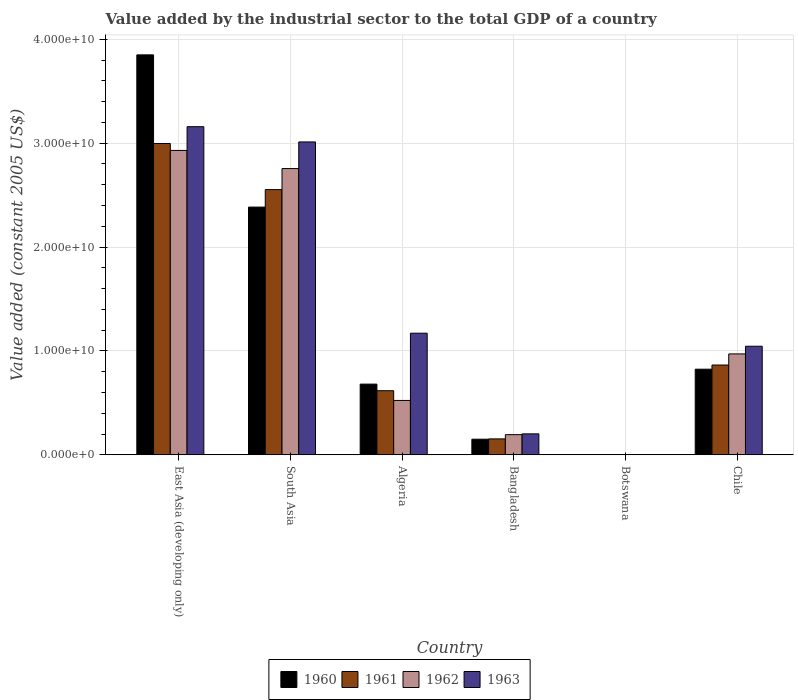How many groups of bars are there?
Offer a terse response. 6. Are the number of bars on each tick of the X-axis equal?
Provide a succinct answer. Yes. How many bars are there on the 2nd tick from the right?
Ensure brevity in your answer.  4. What is the value added by the industrial sector in 1963 in Chile?
Make the answer very short. 1.04e+1. Across all countries, what is the maximum value added by the industrial sector in 1963?
Your answer should be very brief. 3.16e+1. Across all countries, what is the minimum value added by the industrial sector in 1961?
Ensure brevity in your answer.  1.92e+07. In which country was the value added by the industrial sector in 1960 maximum?
Provide a succinct answer. East Asia (developing only). In which country was the value added by the industrial sector in 1961 minimum?
Provide a short and direct response. Botswana. What is the total value added by the industrial sector in 1962 in the graph?
Your response must be concise. 7.37e+1. What is the difference between the value added by the industrial sector in 1960 in Bangladesh and that in South Asia?
Your answer should be compact. -2.23e+1. What is the difference between the value added by the industrial sector in 1963 in Chile and the value added by the industrial sector in 1961 in Bangladesh?
Offer a very short reply. 8.92e+09. What is the average value added by the industrial sector in 1961 per country?
Provide a succinct answer. 1.20e+1. What is the difference between the value added by the industrial sector of/in 1963 and value added by the industrial sector of/in 1962 in Botswana?
Your answer should be compact. -1.48e+06. In how many countries, is the value added by the industrial sector in 1962 greater than 18000000000 US$?
Give a very brief answer. 2. What is the ratio of the value added by the industrial sector in 1963 in East Asia (developing only) to that in South Asia?
Your answer should be compact. 1.05. What is the difference between the highest and the second highest value added by the industrial sector in 1961?
Provide a succinct answer. 4.43e+09. What is the difference between the highest and the lowest value added by the industrial sector in 1962?
Your response must be concise. 2.93e+1. In how many countries, is the value added by the industrial sector in 1962 greater than the average value added by the industrial sector in 1962 taken over all countries?
Provide a succinct answer. 2. Is the sum of the value added by the industrial sector in 1961 in Bangladesh and South Asia greater than the maximum value added by the industrial sector in 1962 across all countries?
Your response must be concise. No. Are all the bars in the graph horizontal?
Offer a terse response. No. Does the graph contain grids?
Offer a terse response. Yes. How are the legend labels stacked?
Your answer should be very brief. Horizontal. What is the title of the graph?
Your answer should be compact. Value added by the industrial sector to the total GDP of a country. What is the label or title of the Y-axis?
Your response must be concise. Value added (constant 2005 US$). What is the Value added (constant 2005 US$) in 1960 in East Asia (developing only)?
Your response must be concise. 3.85e+1. What is the Value added (constant 2005 US$) of 1961 in East Asia (developing only)?
Ensure brevity in your answer.  3.00e+1. What is the Value added (constant 2005 US$) in 1962 in East Asia (developing only)?
Your answer should be compact. 2.93e+1. What is the Value added (constant 2005 US$) in 1963 in East Asia (developing only)?
Provide a succinct answer. 3.16e+1. What is the Value added (constant 2005 US$) in 1960 in South Asia?
Your answer should be very brief. 2.38e+1. What is the Value added (constant 2005 US$) of 1961 in South Asia?
Your answer should be very brief. 2.55e+1. What is the Value added (constant 2005 US$) of 1962 in South Asia?
Your response must be concise. 2.76e+1. What is the Value added (constant 2005 US$) of 1963 in South Asia?
Offer a very short reply. 3.01e+1. What is the Value added (constant 2005 US$) of 1960 in Algeria?
Keep it short and to the point. 6.80e+09. What is the Value added (constant 2005 US$) of 1961 in Algeria?
Provide a short and direct response. 6.17e+09. What is the Value added (constant 2005 US$) in 1962 in Algeria?
Your answer should be compact. 5.23e+09. What is the Value added (constant 2005 US$) in 1963 in Algeria?
Provide a succinct answer. 1.17e+1. What is the Value added (constant 2005 US$) in 1960 in Bangladesh?
Give a very brief answer. 1.50e+09. What is the Value added (constant 2005 US$) of 1961 in Bangladesh?
Keep it short and to the point. 1.53e+09. What is the Value added (constant 2005 US$) of 1962 in Bangladesh?
Offer a very short reply. 1.94e+09. What is the Value added (constant 2005 US$) in 1963 in Bangladesh?
Offer a terse response. 2.01e+09. What is the Value added (constant 2005 US$) of 1960 in Botswana?
Provide a succinct answer. 1.96e+07. What is the Value added (constant 2005 US$) of 1961 in Botswana?
Your answer should be compact. 1.92e+07. What is the Value added (constant 2005 US$) in 1962 in Botswana?
Keep it short and to the point. 1.98e+07. What is the Value added (constant 2005 US$) of 1963 in Botswana?
Offer a very short reply. 1.83e+07. What is the Value added (constant 2005 US$) in 1960 in Chile?
Give a very brief answer. 8.24e+09. What is the Value added (constant 2005 US$) of 1961 in Chile?
Provide a succinct answer. 8.64e+09. What is the Value added (constant 2005 US$) of 1962 in Chile?
Provide a short and direct response. 9.71e+09. What is the Value added (constant 2005 US$) of 1963 in Chile?
Ensure brevity in your answer.  1.04e+1. Across all countries, what is the maximum Value added (constant 2005 US$) in 1960?
Your response must be concise. 3.85e+1. Across all countries, what is the maximum Value added (constant 2005 US$) in 1961?
Your answer should be compact. 3.00e+1. Across all countries, what is the maximum Value added (constant 2005 US$) in 1962?
Provide a short and direct response. 2.93e+1. Across all countries, what is the maximum Value added (constant 2005 US$) in 1963?
Provide a succinct answer. 3.16e+1. Across all countries, what is the minimum Value added (constant 2005 US$) in 1960?
Provide a short and direct response. 1.96e+07. Across all countries, what is the minimum Value added (constant 2005 US$) of 1961?
Provide a short and direct response. 1.92e+07. Across all countries, what is the minimum Value added (constant 2005 US$) in 1962?
Your answer should be very brief. 1.98e+07. Across all countries, what is the minimum Value added (constant 2005 US$) of 1963?
Keep it short and to the point. 1.83e+07. What is the total Value added (constant 2005 US$) in 1960 in the graph?
Offer a terse response. 7.89e+1. What is the total Value added (constant 2005 US$) of 1961 in the graph?
Keep it short and to the point. 7.18e+1. What is the total Value added (constant 2005 US$) of 1962 in the graph?
Ensure brevity in your answer.  7.37e+1. What is the total Value added (constant 2005 US$) in 1963 in the graph?
Offer a very short reply. 8.59e+1. What is the difference between the Value added (constant 2005 US$) in 1960 in East Asia (developing only) and that in South Asia?
Ensure brevity in your answer.  1.47e+1. What is the difference between the Value added (constant 2005 US$) in 1961 in East Asia (developing only) and that in South Asia?
Offer a terse response. 4.43e+09. What is the difference between the Value added (constant 2005 US$) of 1962 in East Asia (developing only) and that in South Asia?
Provide a short and direct response. 1.74e+09. What is the difference between the Value added (constant 2005 US$) of 1963 in East Asia (developing only) and that in South Asia?
Ensure brevity in your answer.  1.47e+09. What is the difference between the Value added (constant 2005 US$) in 1960 in East Asia (developing only) and that in Algeria?
Give a very brief answer. 3.17e+1. What is the difference between the Value added (constant 2005 US$) of 1961 in East Asia (developing only) and that in Algeria?
Ensure brevity in your answer.  2.38e+1. What is the difference between the Value added (constant 2005 US$) in 1962 in East Asia (developing only) and that in Algeria?
Keep it short and to the point. 2.41e+1. What is the difference between the Value added (constant 2005 US$) in 1963 in East Asia (developing only) and that in Algeria?
Ensure brevity in your answer.  1.99e+1. What is the difference between the Value added (constant 2005 US$) of 1960 in East Asia (developing only) and that in Bangladesh?
Offer a terse response. 3.70e+1. What is the difference between the Value added (constant 2005 US$) of 1961 in East Asia (developing only) and that in Bangladesh?
Give a very brief answer. 2.84e+1. What is the difference between the Value added (constant 2005 US$) in 1962 in East Asia (developing only) and that in Bangladesh?
Your answer should be very brief. 2.74e+1. What is the difference between the Value added (constant 2005 US$) of 1963 in East Asia (developing only) and that in Bangladesh?
Ensure brevity in your answer.  2.96e+1. What is the difference between the Value added (constant 2005 US$) of 1960 in East Asia (developing only) and that in Botswana?
Keep it short and to the point. 3.85e+1. What is the difference between the Value added (constant 2005 US$) in 1961 in East Asia (developing only) and that in Botswana?
Keep it short and to the point. 2.99e+1. What is the difference between the Value added (constant 2005 US$) in 1962 in East Asia (developing only) and that in Botswana?
Your answer should be very brief. 2.93e+1. What is the difference between the Value added (constant 2005 US$) in 1963 in East Asia (developing only) and that in Botswana?
Make the answer very short. 3.16e+1. What is the difference between the Value added (constant 2005 US$) in 1960 in East Asia (developing only) and that in Chile?
Offer a terse response. 3.03e+1. What is the difference between the Value added (constant 2005 US$) of 1961 in East Asia (developing only) and that in Chile?
Offer a terse response. 2.13e+1. What is the difference between the Value added (constant 2005 US$) in 1962 in East Asia (developing only) and that in Chile?
Offer a terse response. 1.96e+1. What is the difference between the Value added (constant 2005 US$) of 1963 in East Asia (developing only) and that in Chile?
Keep it short and to the point. 2.11e+1. What is the difference between the Value added (constant 2005 US$) of 1960 in South Asia and that in Algeria?
Offer a terse response. 1.70e+1. What is the difference between the Value added (constant 2005 US$) in 1961 in South Asia and that in Algeria?
Provide a short and direct response. 1.94e+1. What is the difference between the Value added (constant 2005 US$) of 1962 in South Asia and that in Algeria?
Your answer should be compact. 2.23e+1. What is the difference between the Value added (constant 2005 US$) of 1963 in South Asia and that in Algeria?
Your answer should be very brief. 1.84e+1. What is the difference between the Value added (constant 2005 US$) in 1960 in South Asia and that in Bangladesh?
Your answer should be very brief. 2.23e+1. What is the difference between the Value added (constant 2005 US$) in 1961 in South Asia and that in Bangladesh?
Make the answer very short. 2.40e+1. What is the difference between the Value added (constant 2005 US$) in 1962 in South Asia and that in Bangladesh?
Your response must be concise. 2.56e+1. What is the difference between the Value added (constant 2005 US$) in 1963 in South Asia and that in Bangladesh?
Give a very brief answer. 2.81e+1. What is the difference between the Value added (constant 2005 US$) of 1960 in South Asia and that in Botswana?
Give a very brief answer. 2.38e+1. What is the difference between the Value added (constant 2005 US$) in 1961 in South Asia and that in Botswana?
Your answer should be very brief. 2.55e+1. What is the difference between the Value added (constant 2005 US$) in 1962 in South Asia and that in Botswana?
Offer a terse response. 2.75e+1. What is the difference between the Value added (constant 2005 US$) in 1963 in South Asia and that in Botswana?
Make the answer very short. 3.01e+1. What is the difference between the Value added (constant 2005 US$) of 1960 in South Asia and that in Chile?
Ensure brevity in your answer.  1.56e+1. What is the difference between the Value added (constant 2005 US$) in 1961 in South Asia and that in Chile?
Ensure brevity in your answer.  1.69e+1. What is the difference between the Value added (constant 2005 US$) in 1962 in South Asia and that in Chile?
Keep it short and to the point. 1.78e+1. What is the difference between the Value added (constant 2005 US$) of 1963 in South Asia and that in Chile?
Provide a succinct answer. 1.97e+1. What is the difference between the Value added (constant 2005 US$) in 1960 in Algeria and that in Bangladesh?
Make the answer very short. 5.30e+09. What is the difference between the Value added (constant 2005 US$) of 1961 in Algeria and that in Bangladesh?
Offer a very short reply. 4.64e+09. What is the difference between the Value added (constant 2005 US$) of 1962 in Algeria and that in Bangladesh?
Your answer should be very brief. 3.29e+09. What is the difference between the Value added (constant 2005 US$) of 1963 in Algeria and that in Bangladesh?
Your answer should be compact. 9.69e+09. What is the difference between the Value added (constant 2005 US$) of 1960 in Algeria and that in Botswana?
Ensure brevity in your answer.  6.78e+09. What is the difference between the Value added (constant 2005 US$) of 1961 in Algeria and that in Botswana?
Offer a terse response. 6.15e+09. What is the difference between the Value added (constant 2005 US$) of 1962 in Algeria and that in Botswana?
Provide a short and direct response. 5.21e+09. What is the difference between the Value added (constant 2005 US$) in 1963 in Algeria and that in Botswana?
Offer a terse response. 1.17e+1. What is the difference between the Value added (constant 2005 US$) in 1960 in Algeria and that in Chile?
Offer a very short reply. -1.44e+09. What is the difference between the Value added (constant 2005 US$) of 1961 in Algeria and that in Chile?
Your answer should be very brief. -2.47e+09. What is the difference between the Value added (constant 2005 US$) of 1962 in Algeria and that in Chile?
Keep it short and to the point. -4.48e+09. What is the difference between the Value added (constant 2005 US$) in 1963 in Algeria and that in Chile?
Make the answer very short. 1.26e+09. What is the difference between the Value added (constant 2005 US$) in 1960 in Bangladesh and that in Botswana?
Offer a very short reply. 1.48e+09. What is the difference between the Value added (constant 2005 US$) in 1961 in Bangladesh and that in Botswana?
Your response must be concise. 1.51e+09. What is the difference between the Value added (constant 2005 US$) in 1962 in Bangladesh and that in Botswana?
Your answer should be compact. 1.92e+09. What is the difference between the Value added (constant 2005 US$) of 1963 in Bangladesh and that in Botswana?
Keep it short and to the point. 2.00e+09. What is the difference between the Value added (constant 2005 US$) in 1960 in Bangladesh and that in Chile?
Provide a short and direct response. -6.74e+09. What is the difference between the Value added (constant 2005 US$) in 1961 in Bangladesh and that in Chile?
Ensure brevity in your answer.  -7.11e+09. What is the difference between the Value added (constant 2005 US$) of 1962 in Bangladesh and that in Chile?
Your answer should be compact. -7.77e+09. What is the difference between the Value added (constant 2005 US$) in 1963 in Bangladesh and that in Chile?
Keep it short and to the point. -8.43e+09. What is the difference between the Value added (constant 2005 US$) in 1960 in Botswana and that in Chile?
Keep it short and to the point. -8.22e+09. What is the difference between the Value added (constant 2005 US$) in 1961 in Botswana and that in Chile?
Make the answer very short. -8.62e+09. What is the difference between the Value added (constant 2005 US$) of 1962 in Botswana and that in Chile?
Offer a terse response. -9.69e+09. What is the difference between the Value added (constant 2005 US$) in 1963 in Botswana and that in Chile?
Ensure brevity in your answer.  -1.04e+1. What is the difference between the Value added (constant 2005 US$) in 1960 in East Asia (developing only) and the Value added (constant 2005 US$) in 1961 in South Asia?
Your answer should be very brief. 1.30e+1. What is the difference between the Value added (constant 2005 US$) of 1960 in East Asia (developing only) and the Value added (constant 2005 US$) of 1962 in South Asia?
Your answer should be compact. 1.09e+1. What is the difference between the Value added (constant 2005 US$) in 1960 in East Asia (developing only) and the Value added (constant 2005 US$) in 1963 in South Asia?
Provide a short and direct response. 8.38e+09. What is the difference between the Value added (constant 2005 US$) of 1961 in East Asia (developing only) and the Value added (constant 2005 US$) of 1962 in South Asia?
Offer a terse response. 2.41e+09. What is the difference between the Value added (constant 2005 US$) of 1961 in East Asia (developing only) and the Value added (constant 2005 US$) of 1963 in South Asia?
Provide a succinct answer. -1.54e+08. What is the difference between the Value added (constant 2005 US$) of 1962 in East Asia (developing only) and the Value added (constant 2005 US$) of 1963 in South Asia?
Offer a very short reply. -8.18e+08. What is the difference between the Value added (constant 2005 US$) of 1960 in East Asia (developing only) and the Value added (constant 2005 US$) of 1961 in Algeria?
Keep it short and to the point. 3.23e+1. What is the difference between the Value added (constant 2005 US$) of 1960 in East Asia (developing only) and the Value added (constant 2005 US$) of 1962 in Algeria?
Your response must be concise. 3.33e+1. What is the difference between the Value added (constant 2005 US$) in 1960 in East Asia (developing only) and the Value added (constant 2005 US$) in 1963 in Algeria?
Make the answer very short. 2.68e+1. What is the difference between the Value added (constant 2005 US$) of 1961 in East Asia (developing only) and the Value added (constant 2005 US$) of 1962 in Algeria?
Provide a short and direct response. 2.47e+1. What is the difference between the Value added (constant 2005 US$) in 1961 in East Asia (developing only) and the Value added (constant 2005 US$) in 1963 in Algeria?
Make the answer very short. 1.83e+1. What is the difference between the Value added (constant 2005 US$) in 1962 in East Asia (developing only) and the Value added (constant 2005 US$) in 1963 in Algeria?
Provide a succinct answer. 1.76e+1. What is the difference between the Value added (constant 2005 US$) of 1960 in East Asia (developing only) and the Value added (constant 2005 US$) of 1961 in Bangladesh?
Offer a terse response. 3.70e+1. What is the difference between the Value added (constant 2005 US$) of 1960 in East Asia (developing only) and the Value added (constant 2005 US$) of 1962 in Bangladesh?
Keep it short and to the point. 3.66e+1. What is the difference between the Value added (constant 2005 US$) in 1960 in East Asia (developing only) and the Value added (constant 2005 US$) in 1963 in Bangladesh?
Your answer should be very brief. 3.65e+1. What is the difference between the Value added (constant 2005 US$) in 1961 in East Asia (developing only) and the Value added (constant 2005 US$) in 1962 in Bangladesh?
Keep it short and to the point. 2.80e+1. What is the difference between the Value added (constant 2005 US$) in 1961 in East Asia (developing only) and the Value added (constant 2005 US$) in 1963 in Bangladesh?
Provide a succinct answer. 2.79e+1. What is the difference between the Value added (constant 2005 US$) of 1962 in East Asia (developing only) and the Value added (constant 2005 US$) of 1963 in Bangladesh?
Offer a terse response. 2.73e+1. What is the difference between the Value added (constant 2005 US$) in 1960 in East Asia (developing only) and the Value added (constant 2005 US$) in 1961 in Botswana?
Provide a succinct answer. 3.85e+1. What is the difference between the Value added (constant 2005 US$) of 1960 in East Asia (developing only) and the Value added (constant 2005 US$) of 1962 in Botswana?
Give a very brief answer. 3.85e+1. What is the difference between the Value added (constant 2005 US$) of 1960 in East Asia (developing only) and the Value added (constant 2005 US$) of 1963 in Botswana?
Your answer should be compact. 3.85e+1. What is the difference between the Value added (constant 2005 US$) of 1961 in East Asia (developing only) and the Value added (constant 2005 US$) of 1962 in Botswana?
Offer a terse response. 2.99e+1. What is the difference between the Value added (constant 2005 US$) in 1961 in East Asia (developing only) and the Value added (constant 2005 US$) in 1963 in Botswana?
Your answer should be compact. 2.99e+1. What is the difference between the Value added (constant 2005 US$) of 1962 in East Asia (developing only) and the Value added (constant 2005 US$) of 1963 in Botswana?
Provide a short and direct response. 2.93e+1. What is the difference between the Value added (constant 2005 US$) in 1960 in East Asia (developing only) and the Value added (constant 2005 US$) in 1961 in Chile?
Your response must be concise. 2.99e+1. What is the difference between the Value added (constant 2005 US$) of 1960 in East Asia (developing only) and the Value added (constant 2005 US$) of 1962 in Chile?
Give a very brief answer. 2.88e+1. What is the difference between the Value added (constant 2005 US$) in 1960 in East Asia (developing only) and the Value added (constant 2005 US$) in 1963 in Chile?
Offer a very short reply. 2.80e+1. What is the difference between the Value added (constant 2005 US$) of 1961 in East Asia (developing only) and the Value added (constant 2005 US$) of 1962 in Chile?
Your answer should be compact. 2.02e+1. What is the difference between the Value added (constant 2005 US$) of 1961 in East Asia (developing only) and the Value added (constant 2005 US$) of 1963 in Chile?
Offer a very short reply. 1.95e+1. What is the difference between the Value added (constant 2005 US$) of 1962 in East Asia (developing only) and the Value added (constant 2005 US$) of 1963 in Chile?
Provide a short and direct response. 1.88e+1. What is the difference between the Value added (constant 2005 US$) of 1960 in South Asia and the Value added (constant 2005 US$) of 1961 in Algeria?
Your answer should be compact. 1.77e+1. What is the difference between the Value added (constant 2005 US$) in 1960 in South Asia and the Value added (constant 2005 US$) in 1962 in Algeria?
Your answer should be compact. 1.86e+1. What is the difference between the Value added (constant 2005 US$) of 1960 in South Asia and the Value added (constant 2005 US$) of 1963 in Algeria?
Your answer should be very brief. 1.21e+1. What is the difference between the Value added (constant 2005 US$) in 1961 in South Asia and the Value added (constant 2005 US$) in 1962 in Algeria?
Give a very brief answer. 2.03e+1. What is the difference between the Value added (constant 2005 US$) of 1961 in South Asia and the Value added (constant 2005 US$) of 1963 in Algeria?
Make the answer very short. 1.38e+1. What is the difference between the Value added (constant 2005 US$) of 1962 in South Asia and the Value added (constant 2005 US$) of 1963 in Algeria?
Your answer should be very brief. 1.58e+1. What is the difference between the Value added (constant 2005 US$) in 1960 in South Asia and the Value added (constant 2005 US$) in 1961 in Bangladesh?
Offer a terse response. 2.23e+1. What is the difference between the Value added (constant 2005 US$) of 1960 in South Asia and the Value added (constant 2005 US$) of 1962 in Bangladesh?
Give a very brief answer. 2.19e+1. What is the difference between the Value added (constant 2005 US$) in 1960 in South Asia and the Value added (constant 2005 US$) in 1963 in Bangladesh?
Provide a succinct answer. 2.18e+1. What is the difference between the Value added (constant 2005 US$) in 1961 in South Asia and the Value added (constant 2005 US$) in 1962 in Bangladesh?
Keep it short and to the point. 2.36e+1. What is the difference between the Value added (constant 2005 US$) in 1961 in South Asia and the Value added (constant 2005 US$) in 1963 in Bangladesh?
Offer a very short reply. 2.35e+1. What is the difference between the Value added (constant 2005 US$) of 1962 in South Asia and the Value added (constant 2005 US$) of 1963 in Bangladesh?
Offer a terse response. 2.55e+1. What is the difference between the Value added (constant 2005 US$) in 1960 in South Asia and the Value added (constant 2005 US$) in 1961 in Botswana?
Offer a very short reply. 2.38e+1. What is the difference between the Value added (constant 2005 US$) in 1960 in South Asia and the Value added (constant 2005 US$) in 1962 in Botswana?
Make the answer very short. 2.38e+1. What is the difference between the Value added (constant 2005 US$) of 1960 in South Asia and the Value added (constant 2005 US$) of 1963 in Botswana?
Your response must be concise. 2.38e+1. What is the difference between the Value added (constant 2005 US$) in 1961 in South Asia and the Value added (constant 2005 US$) in 1962 in Botswana?
Provide a succinct answer. 2.55e+1. What is the difference between the Value added (constant 2005 US$) in 1961 in South Asia and the Value added (constant 2005 US$) in 1963 in Botswana?
Keep it short and to the point. 2.55e+1. What is the difference between the Value added (constant 2005 US$) in 1962 in South Asia and the Value added (constant 2005 US$) in 1963 in Botswana?
Provide a short and direct response. 2.75e+1. What is the difference between the Value added (constant 2005 US$) of 1960 in South Asia and the Value added (constant 2005 US$) of 1961 in Chile?
Keep it short and to the point. 1.52e+1. What is the difference between the Value added (constant 2005 US$) of 1960 in South Asia and the Value added (constant 2005 US$) of 1962 in Chile?
Provide a succinct answer. 1.41e+1. What is the difference between the Value added (constant 2005 US$) in 1960 in South Asia and the Value added (constant 2005 US$) in 1963 in Chile?
Ensure brevity in your answer.  1.34e+1. What is the difference between the Value added (constant 2005 US$) of 1961 in South Asia and the Value added (constant 2005 US$) of 1962 in Chile?
Offer a very short reply. 1.58e+1. What is the difference between the Value added (constant 2005 US$) of 1961 in South Asia and the Value added (constant 2005 US$) of 1963 in Chile?
Your response must be concise. 1.51e+1. What is the difference between the Value added (constant 2005 US$) of 1962 in South Asia and the Value added (constant 2005 US$) of 1963 in Chile?
Your answer should be compact. 1.71e+1. What is the difference between the Value added (constant 2005 US$) of 1960 in Algeria and the Value added (constant 2005 US$) of 1961 in Bangladesh?
Offer a terse response. 5.27e+09. What is the difference between the Value added (constant 2005 US$) of 1960 in Algeria and the Value added (constant 2005 US$) of 1962 in Bangladesh?
Make the answer very short. 4.86e+09. What is the difference between the Value added (constant 2005 US$) in 1960 in Algeria and the Value added (constant 2005 US$) in 1963 in Bangladesh?
Provide a short and direct response. 4.79e+09. What is the difference between the Value added (constant 2005 US$) of 1961 in Algeria and the Value added (constant 2005 US$) of 1962 in Bangladesh?
Ensure brevity in your answer.  4.23e+09. What is the difference between the Value added (constant 2005 US$) of 1961 in Algeria and the Value added (constant 2005 US$) of 1963 in Bangladesh?
Offer a very short reply. 4.15e+09. What is the difference between the Value added (constant 2005 US$) in 1962 in Algeria and the Value added (constant 2005 US$) in 1963 in Bangladesh?
Your answer should be very brief. 3.22e+09. What is the difference between the Value added (constant 2005 US$) in 1960 in Algeria and the Value added (constant 2005 US$) in 1961 in Botswana?
Your answer should be very brief. 6.78e+09. What is the difference between the Value added (constant 2005 US$) of 1960 in Algeria and the Value added (constant 2005 US$) of 1962 in Botswana?
Provide a succinct answer. 6.78e+09. What is the difference between the Value added (constant 2005 US$) in 1960 in Algeria and the Value added (constant 2005 US$) in 1963 in Botswana?
Offer a very short reply. 6.78e+09. What is the difference between the Value added (constant 2005 US$) in 1961 in Algeria and the Value added (constant 2005 US$) in 1962 in Botswana?
Your answer should be compact. 6.15e+09. What is the difference between the Value added (constant 2005 US$) of 1961 in Algeria and the Value added (constant 2005 US$) of 1963 in Botswana?
Your answer should be compact. 6.15e+09. What is the difference between the Value added (constant 2005 US$) in 1962 in Algeria and the Value added (constant 2005 US$) in 1963 in Botswana?
Your answer should be very brief. 5.21e+09. What is the difference between the Value added (constant 2005 US$) in 1960 in Algeria and the Value added (constant 2005 US$) in 1961 in Chile?
Your answer should be compact. -1.84e+09. What is the difference between the Value added (constant 2005 US$) in 1960 in Algeria and the Value added (constant 2005 US$) in 1962 in Chile?
Ensure brevity in your answer.  -2.91e+09. What is the difference between the Value added (constant 2005 US$) of 1960 in Algeria and the Value added (constant 2005 US$) of 1963 in Chile?
Your answer should be compact. -3.65e+09. What is the difference between the Value added (constant 2005 US$) in 1961 in Algeria and the Value added (constant 2005 US$) in 1962 in Chile?
Ensure brevity in your answer.  -3.54e+09. What is the difference between the Value added (constant 2005 US$) of 1961 in Algeria and the Value added (constant 2005 US$) of 1963 in Chile?
Make the answer very short. -4.28e+09. What is the difference between the Value added (constant 2005 US$) in 1962 in Algeria and the Value added (constant 2005 US$) in 1963 in Chile?
Offer a terse response. -5.22e+09. What is the difference between the Value added (constant 2005 US$) in 1960 in Bangladesh and the Value added (constant 2005 US$) in 1961 in Botswana?
Offer a very short reply. 1.48e+09. What is the difference between the Value added (constant 2005 US$) in 1960 in Bangladesh and the Value added (constant 2005 US$) in 1962 in Botswana?
Your answer should be very brief. 1.48e+09. What is the difference between the Value added (constant 2005 US$) in 1960 in Bangladesh and the Value added (constant 2005 US$) in 1963 in Botswana?
Provide a succinct answer. 1.48e+09. What is the difference between the Value added (constant 2005 US$) in 1961 in Bangladesh and the Value added (constant 2005 US$) in 1962 in Botswana?
Provide a short and direct response. 1.51e+09. What is the difference between the Value added (constant 2005 US$) in 1961 in Bangladesh and the Value added (constant 2005 US$) in 1963 in Botswana?
Provide a short and direct response. 1.51e+09. What is the difference between the Value added (constant 2005 US$) in 1962 in Bangladesh and the Value added (constant 2005 US$) in 1963 in Botswana?
Offer a very short reply. 1.92e+09. What is the difference between the Value added (constant 2005 US$) in 1960 in Bangladesh and the Value added (constant 2005 US$) in 1961 in Chile?
Your answer should be very brief. -7.14e+09. What is the difference between the Value added (constant 2005 US$) of 1960 in Bangladesh and the Value added (constant 2005 US$) of 1962 in Chile?
Your answer should be compact. -8.21e+09. What is the difference between the Value added (constant 2005 US$) of 1960 in Bangladesh and the Value added (constant 2005 US$) of 1963 in Chile?
Make the answer very short. -8.95e+09. What is the difference between the Value added (constant 2005 US$) of 1961 in Bangladesh and the Value added (constant 2005 US$) of 1962 in Chile?
Provide a short and direct response. -8.18e+09. What is the difference between the Value added (constant 2005 US$) of 1961 in Bangladesh and the Value added (constant 2005 US$) of 1963 in Chile?
Offer a very short reply. -8.92e+09. What is the difference between the Value added (constant 2005 US$) in 1962 in Bangladesh and the Value added (constant 2005 US$) in 1963 in Chile?
Give a very brief answer. -8.51e+09. What is the difference between the Value added (constant 2005 US$) in 1960 in Botswana and the Value added (constant 2005 US$) in 1961 in Chile?
Provide a short and direct response. -8.62e+09. What is the difference between the Value added (constant 2005 US$) in 1960 in Botswana and the Value added (constant 2005 US$) in 1962 in Chile?
Your response must be concise. -9.69e+09. What is the difference between the Value added (constant 2005 US$) of 1960 in Botswana and the Value added (constant 2005 US$) of 1963 in Chile?
Ensure brevity in your answer.  -1.04e+1. What is the difference between the Value added (constant 2005 US$) of 1961 in Botswana and the Value added (constant 2005 US$) of 1962 in Chile?
Your response must be concise. -9.69e+09. What is the difference between the Value added (constant 2005 US$) of 1961 in Botswana and the Value added (constant 2005 US$) of 1963 in Chile?
Provide a succinct answer. -1.04e+1. What is the difference between the Value added (constant 2005 US$) in 1962 in Botswana and the Value added (constant 2005 US$) in 1963 in Chile?
Make the answer very short. -1.04e+1. What is the average Value added (constant 2005 US$) of 1960 per country?
Your answer should be very brief. 1.31e+1. What is the average Value added (constant 2005 US$) in 1961 per country?
Offer a terse response. 1.20e+1. What is the average Value added (constant 2005 US$) in 1962 per country?
Your answer should be very brief. 1.23e+1. What is the average Value added (constant 2005 US$) of 1963 per country?
Your answer should be very brief. 1.43e+1. What is the difference between the Value added (constant 2005 US$) of 1960 and Value added (constant 2005 US$) of 1961 in East Asia (developing only)?
Provide a succinct answer. 8.53e+09. What is the difference between the Value added (constant 2005 US$) in 1960 and Value added (constant 2005 US$) in 1962 in East Asia (developing only)?
Give a very brief answer. 9.20e+09. What is the difference between the Value added (constant 2005 US$) in 1960 and Value added (constant 2005 US$) in 1963 in East Asia (developing only)?
Provide a succinct answer. 6.91e+09. What is the difference between the Value added (constant 2005 US$) in 1961 and Value added (constant 2005 US$) in 1962 in East Asia (developing only)?
Offer a terse response. 6.65e+08. What is the difference between the Value added (constant 2005 US$) of 1961 and Value added (constant 2005 US$) of 1963 in East Asia (developing only)?
Offer a terse response. -1.62e+09. What is the difference between the Value added (constant 2005 US$) in 1962 and Value added (constant 2005 US$) in 1963 in East Asia (developing only)?
Offer a terse response. -2.29e+09. What is the difference between the Value added (constant 2005 US$) in 1960 and Value added (constant 2005 US$) in 1961 in South Asia?
Your response must be concise. -1.68e+09. What is the difference between the Value added (constant 2005 US$) of 1960 and Value added (constant 2005 US$) of 1962 in South Asia?
Offer a very short reply. -3.71e+09. What is the difference between the Value added (constant 2005 US$) in 1960 and Value added (constant 2005 US$) in 1963 in South Asia?
Your answer should be very brief. -6.27e+09. What is the difference between the Value added (constant 2005 US$) in 1961 and Value added (constant 2005 US$) in 1962 in South Asia?
Make the answer very short. -2.02e+09. What is the difference between the Value added (constant 2005 US$) of 1961 and Value added (constant 2005 US$) of 1963 in South Asia?
Offer a terse response. -4.59e+09. What is the difference between the Value added (constant 2005 US$) in 1962 and Value added (constant 2005 US$) in 1963 in South Asia?
Keep it short and to the point. -2.56e+09. What is the difference between the Value added (constant 2005 US$) of 1960 and Value added (constant 2005 US$) of 1961 in Algeria?
Ensure brevity in your answer.  6.34e+08. What is the difference between the Value added (constant 2005 US$) in 1960 and Value added (constant 2005 US$) in 1962 in Algeria?
Your answer should be very brief. 1.57e+09. What is the difference between the Value added (constant 2005 US$) in 1960 and Value added (constant 2005 US$) in 1963 in Algeria?
Keep it short and to the point. -4.90e+09. What is the difference between the Value added (constant 2005 US$) of 1961 and Value added (constant 2005 US$) of 1962 in Algeria?
Provide a succinct answer. 9.37e+08. What is the difference between the Value added (constant 2005 US$) in 1961 and Value added (constant 2005 US$) in 1963 in Algeria?
Your answer should be very brief. -5.54e+09. What is the difference between the Value added (constant 2005 US$) in 1962 and Value added (constant 2005 US$) in 1963 in Algeria?
Your answer should be compact. -6.47e+09. What is the difference between the Value added (constant 2005 US$) of 1960 and Value added (constant 2005 US$) of 1961 in Bangladesh?
Provide a succinct answer. -3.05e+07. What is the difference between the Value added (constant 2005 US$) in 1960 and Value added (constant 2005 US$) in 1962 in Bangladesh?
Provide a succinct answer. -4.38e+08. What is the difference between the Value added (constant 2005 US$) of 1960 and Value added (constant 2005 US$) of 1963 in Bangladesh?
Ensure brevity in your answer.  -5.14e+08. What is the difference between the Value added (constant 2005 US$) in 1961 and Value added (constant 2005 US$) in 1962 in Bangladesh?
Give a very brief answer. -4.08e+08. What is the difference between the Value added (constant 2005 US$) in 1961 and Value added (constant 2005 US$) in 1963 in Bangladesh?
Your response must be concise. -4.84e+08. What is the difference between the Value added (constant 2005 US$) in 1962 and Value added (constant 2005 US$) in 1963 in Bangladesh?
Offer a very short reply. -7.60e+07. What is the difference between the Value added (constant 2005 US$) of 1960 and Value added (constant 2005 US$) of 1961 in Botswana?
Offer a terse response. 4.24e+05. What is the difference between the Value added (constant 2005 US$) of 1960 and Value added (constant 2005 US$) of 1962 in Botswana?
Keep it short and to the point. -2.12e+05. What is the difference between the Value added (constant 2005 US$) of 1960 and Value added (constant 2005 US$) of 1963 in Botswana?
Offer a very short reply. 1.27e+06. What is the difference between the Value added (constant 2005 US$) in 1961 and Value added (constant 2005 US$) in 1962 in Botswana?
Your response must be concise. -6.36e+05. What is the difference between the Value added (constant 2005 US$) in 1961 and Value added (constant 2005 US$) in 1963 in Botswana?
Offer a very short reply. 8.48e+05. What is the difference between the Value added (constant 2005 US$) in 1962 and Value added (constant 2005 US$) in 1963 in Botswana?
Make the answer very short. 1.48e+06. What is the difference between the Value added (constant 2005 US$) in 1960 and Value added (constant 2005 US$) in 1961 in Chile?
Ensure brevity in your answer.  -4.01e+08. What is the difference between the Value added (constant 2005 US$) of 1960 and Value added (constant 2005 US$) of 1962 in Chile?
Make the answer very short. -1.47e+09. What is the difference between the Value added (constant 2005 US$) of 1960 and Value added (constant 2005 US$) of 1963 in Chile?
Your response must be concise. -2.21e+09. What is the difference between the Value added (constant 2005 US$) of 1961 and Value added (constant 2005 US$) of 1962 in Chile?
Provide a short and direct response. -1.07e+09. What is the difference between the Value added (constant 2005 US$) of 1961 and Value added (constant 2005 US$) of 1963 in Chile?
Offer a terse response. -1.81e+09. What is the difference between the Value added (constant 2005 US$) in 1962 and Value added (constant 2005 US$) in 1963 in Chile?
Offer a terse response. -7.37e+08. What is the ratio of the Value added (constant 2005 US$) of 1960 in East Asia (developing only) to that in South Asia?
Keep it short and to the point. 1.61. What is the ratio of the Value added (constant 2005 US$) of 1961 in East Asia (developing only) to that in South Asia?
Your answer should be compact. 1.17. What is the ratio of the Value added (constant 2005 US$) of 1962 in East Asia (developing only) to that in South Asia?
Your response must be concise. 1.06. What is the ratio of the Value added (constant 2005 US$) of 1963 in East Asia (developing only) to that in South Asia?
Offer a terse response. 1.05. What is the ratio of the Value added (constant 2005 US$) of 1960 in East Asia (developing only) to that in Algeria?
Your answer should be very brief. 5.66. What is the ratio of the Value added (constant 2005 US$) of 1961 in East Asia (developing only) to that in Algeria?
Make the answer very short. 4.86. What is the ratio of the Value added (constant 2005 US$) of 1962 in East Asia (developing only) to that in Algeria?
Make the answer very short. 5.6. What is the ratio of the Value added (constant 2005 US$) of 1963 in East Asia (developing only) to that in Algeria?
Provide a succinct answer. 2.7. What is the ratio of the Value added (constant 2005 US$) of 1960 in East Asia (developing only) to that in Bangladesh?
Provide a succinct answer. 25.66. What is the ratio of the Value added (constant 2005 US$) of 1961 in East Asia (developing only) to that in Bangladesh?
Offer a terse response. 19.57. What is the ratio of the Value added (constant 2005 US$) in 1962 in East Asia (developing only) to that in Bangladesh?
Keep it short and to the point. 15.11. What is the ratio of the Value added (constant 2005 US$) of 1963 in East Asia (developing only) to that in Bangladesh?
Your answer should be very brief. 15.68. What is the ratio of the Value added (constant 2005 US$) of 1960 in East Asia (developing only) to that in Botswana?
Your answer should be compact. 1962.41. What is the ratio of the Value added (constant 2005 US$) of 1961 in East Asia (developing only) to that in Botswana?
Provide a succinct answer. 1561.12. What is the ratio of the Value added (constant 2005 US$) of 1962 in East Asia (developing only) to that in Botswana?
Offer a terse response. 1477.51. What is the ratio of the Value added (constant 2005 US$) in 1963 in East Asia (developing only) to that in Botswana?
Provide a short and direct response. 1721.68. What is the ratio of the Value added (constant 2005 US$) in 1960 in East Asia (developing only) to that in Chile?
Your answer should be very brief. 4.67. What is the ratio of the Value added (constant 2005 US$) in 1961 in East Asia (developing only) to that in Chile?
Make the answer very short. 3.47. What is the ratio of the Value added (constant 2005 US$) of 1962 in East Asia (developing only) to that in Chile?
Keep it short and to the point. 3.02. What is the ratio of the Value added (constant 2005 US$) in 1963 in East Asia (developing only) to that in Chile?
Your response must be concise. 3.02. What is the ratio of the Value added (constant 2005 US$) in 1960 in South Asia to that in Algeria?
Provide a short and direct response. 3.5. What is the ratio of the Value added (constant 2005 US$) of 1961 in South Asia to that in Algeria?
Give a very brief answer. 4.14. What is the ratio of the Value added (constant 2005 US$) in 1962 in South Asia to that in Algeria?
Keep it short and to the point. 5.27. What is the ratio of the Value added (constant 2005 US$) of 1963 in South Asia to that in Algeria?
Make the answer very short. 2.57. What is the ratio of the Value added (constant 2005 US$) in 1960 in South Asia to that in Bangladesh?
Make the answer very short. 15.89. What is the ratio of the Value added (constant 2005 US$) in 1961 in South Asia to that in Bangladesh?
Your answer should be very brief. 16.68. What is the ratio of the Value added (constant 2005 US$) in 1962 in South Asia to that in Bangladesh?
Keep it short and to the point. 14.21. What is the ratio of the Value added (constant 2005 US$) of 1963 in South Asia to that in Bangladesh?
Make the answer very short. 14.95. What is the ratio of the Value added (constant 2005 US$) in 1960 in South Asia to that in Botswana?
Ensure brevity in your answer.  1215.49. What is the ratio of the Value added (constant 2005 US$) of 1961 in South Asia to that in Botswana?
Make the answer very short. 1330.08. What is the ratio of the Value added (constant 2005 US$) in 1962 in South Asia to that in Botswana?
Provide a succinct answer. 1389.51. What is the ratio of the Value added (constant 2005 US$) of 1963 in South Asia to that in Botswana?
Your response must be concise. 1641.69. What is the ratio of the Value added (constant 2005 US$) of 1960 in South Asia to that in Chile?
Offer a very short reply. 2.89. What is the ratio of the Value added (constant 2005 US$) of 1961 in South Asia to that in Chile?
Your answer should be very brief. 2.95. What is the ratio of the Value added (constant 2005 US$) in 1962 in South Asia to that in Chile?
Offer a very short reply. 2.84. What is the ratio of the Value added (constant 2005 US$) of 1963 in South Asia to that in Chile?
Your answer should be compact. 2.88. What is the ratio of the Value added (constant 2005 US$) in 1960 in Algeria to that in Bangladesh?
Provide a succinct answer. 4.53. What is the ratio of the Value added (constant 2005 US$) in 1961 in Algeria to that in Bangladesh?
Your answer should be compact. 4.03. What is the ratio of the Value added (constant 2005 US$) in 1962 in Algeria to that in Bangladesh?
Make the answer very short. 2.7. What is the ratio of the Value added (constant 2005 US$) in 1963 in Algeria to that in Bangladesh?
Offer a terse response. 5.81. What is the ratio of the Value added (constant 2005 US$) of 1960 in Algeria to that in Botswana?
Your response must be concise. 346.79. What is the ratio of the Value added (constant 2005 US$) in 1961 in Algeria to that in Botswana?
Give a very brief answer. 321.41. What is the ratio of the Value added (constant 2005 US$) in 1962 in Algeria to that in Botswana?
Provide a succinct answer. 263.85. What is the ratio of the Value added (constant 2005 US$) in 1963 in Algeria to that in Botswana?
Your response must be concise. 638.08. What is the ratio of the Value added (constant 2005 US$) of 1960 in Algeria to that in Chile?
Offer a very short reply. 0.83. What is the ratio of the Value added (constant 2005 US$) of 1961 in Algeria to that in Chile?
Keep it short and to the point. 0.71. What is the ratio of the Value added (constant 2005 US$) of 1962 in Algeria to that in Chile?
Offer a very short reply. 0.54. What is the ratio of the Value added (constant 2005 US$) in 1963 in Algeria to that in Chile?
Offer a terse response. 1.12. What is the ratio of the Value added (constant 2005 US$) in 1960 in Bangladesh to that in Botswana?
Offer a terse response. 76.48. What is the ratio of the Value added (constant 2005 US$) in 1961 in Bangladesh to that in Botswana?
Your response must be concise. 79.76. What is the ratio of the Value added (constant 2005 US$) of 1962 in Bangladesh to that in Botswana?
Offer a very short reply. 97.78. What is the ratio of the Value added (constant 2005 US$) of 1963 in Bangladesh to that in Botswana?
Provide a succinct answer. 109.83. What is the ratio of the Value added (constant 2005 US$) of 1960 in Bangladesh to that in Chile?
Offer a very short reply. 0.18. What is the ratio of the Value added (constant 2005 US$) of 1961 in Bangladesh to that in Chile?
Offer a terse response. 0.18. What is the ratio of the Value added (constant 2005 US$) of 1962 in Bangladesh to that in Chile?
Make the answer very short. 0.2. What is the ratio of the Value added (constant 2005 US$) of 1963 in Bangladesh to that in Chile?
Your answer should be compact. 0.19. What is the ratio of the Value added (constant 2005 US$) of 1960 in Botswana to that in Chile?
Ensure brevity in your answer.  0. What is the ratio of the Value added (constant 2005 US$) in 1961 in Botswana to that in Chile?
Provide a short and direct response. 0. What is the ratio of the Value added (constant 2005 US$) in 1962 in Botswana to that in Chile?
Provide a short and direct response. 0. What is the ratio of the Value added (constant 2005 US$) of 1963 in Botswana to that in Chile?
Provide a succinct answer. 0. What is the difference between the highest and the second highest Value added (constant 2005 US$) of 1960?
Give a very brief answer. 1.47e+1. What is the difference between the highest and the second highest Value added (constant 2005 US$) in 1961?
Your answer should be very brief. 4.43e+09. What is the difference between the highest and the second highest Value added (constant 2005 US$) in 1962?
Your answer should be very brief. 1.74e+09. What is the difference between the highest and the second highest Value added (constant 2005 US$) in 1963?
Your answer should be compact. 1.47e+09. What is the difference between the highest and the lowest Value added (constant 2005 US$) in 1960?
Make the answer very short. 3.85e+1. What is the difference between the highest and the lowest Value added (constant 2005 US$) of 1961?
Your answer should be compact. 2.99e+1. What is the difference between the highest and the lowest Value added (constant 2005 US$) of 1962?
Your answer should be very brief. 2.93e+1. What is the difference between the highest and the lowest Value added (constant 2005 US$) of 1963?
Provide a succinct answer. 3.16e+1. 